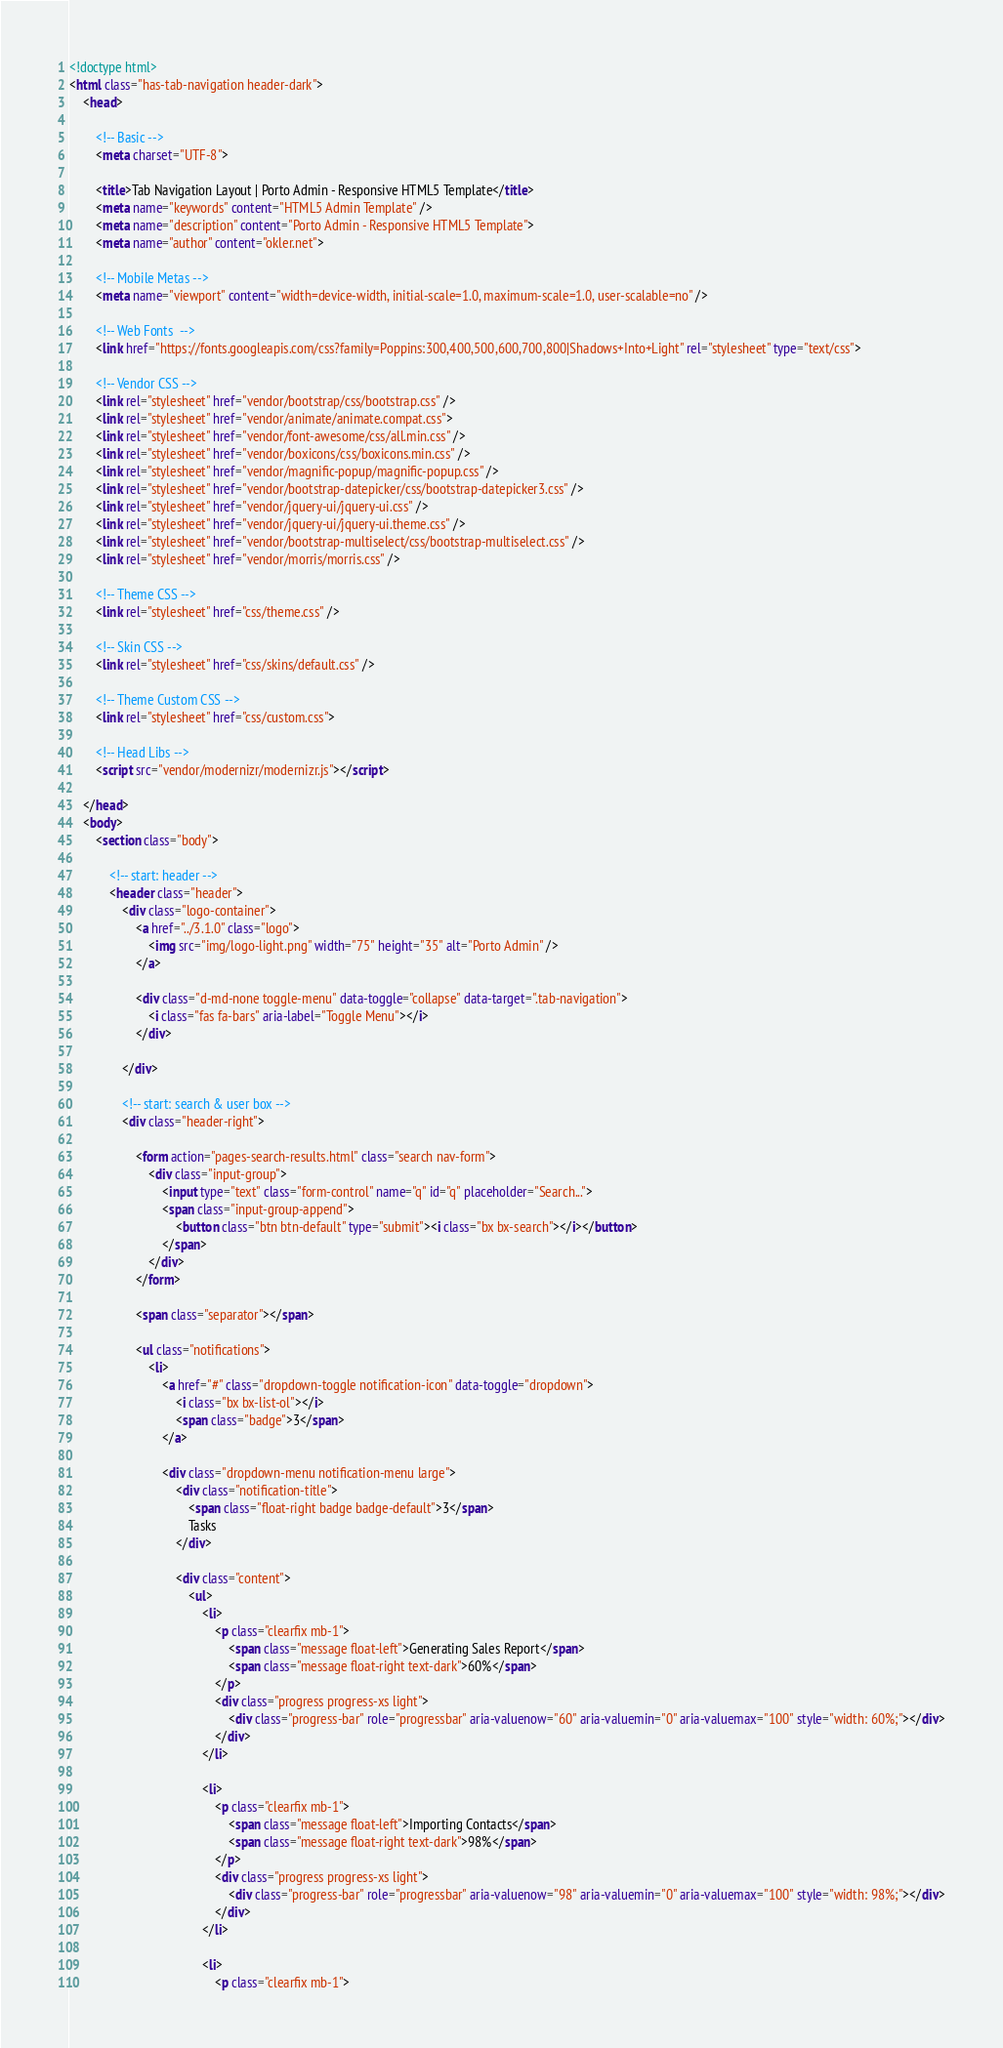Convert code to text. <code><loc_0><loc_0><loc_500><loc_500><_HTML_><!doctype html><html class="has-tab-navigation header-dark">
	<head>
		<!-- Basic -->
		<meta charset="UTF-8">
		<title>Tab Navigation Layout | Porto Admin - Responsive HTML5 Template</title>
		<meta name="keywords" content="HTML5 Admin Template" />
		<meta name="description" content="Porto Admin - Responsive HTML5 Template">
		<meta name="author" content="okler.net">
		<!-- Mobile Metas -->
		<meta name="viewport" content="width=device-width, initial-scale=1.0, maximum-scale=1.0, user-scalable=no" />
		<!-- Web Fonts  -->
		<link href="https://fonts.googleapis.com/css?family=Poppins:300,400,500,600,700,800|Shadows+Into+Light" rel="stylesheet" type="text/css">
		<!-- Vendor CSS -->
		<link rel="stylesheet" href="vendor/bootstrap/css/bootstrap.css" />		<link rel="stylesheet" href="vendor/animate/animate.compat.css">		<link rel="stylesheet" href="vendor/font-awesome/css/all.min.css" />		<link rel="stylesheet" href="vendor/boxicons/css/boxicons.min.css" />		<link rel="stylesheet" href="vendor/magnific-popup/magnific-popup.css" />		<link rel="stylesheet" href="vendor/bootstrap-datepicker/css/bootstrap-datepicker3.css" />		<link rel="stylesheet" href="vendor/jquery-ui/jquery-ui.css" />		<link rel="stylesheet" href="vendor/jquery-ui/jquery-ui.theme.css" />		<link rel="stylesheet" href="vendor/bootstrap-multiselect/css/bootstrap-multiselect.css" />		<link rel="stylesheet" href="vendor/morris/morris.css" />
		<!-- Theme CSS -->
		<link rel="stylesheet" href="css/theme.css" />
		<!-- Skin CSS -->
		<link rel="stylesheet" href="css/skins/default.css" />
		<!-- Theme Custom CSS -->
		<link rel="stylesheet" href="css/custom.css">
		<!-- Head Libs -->
		<script src="vendor/modernizr/modernizr.js"></script>
	</head>
	<body>
		<section class="body">
			<!-- start: header -->
			<header class="header">
				<div class="logo-container">
					<a href="../3.1.0" class="logo">
						<img src="img/logo-light.png" width="75" height="35" alt="Porto Admin" />
					</a>
					<div class="d-md-none toggle-menu" data-toggle="collapse" data-target=".tab-navigation">
						<i class="fas fa-bars" aria-label="Toggle Menu"></i>
					</div>
				</div>
				<!-- start: search & user box -->
				<div class="header-right">
					<form action="pages-search-results.html" class="search nav-form">
						<div class="input-group">
							<input type="text" class="form-control" name="q" id="q" placeholder="Search...">
							<span class="input-group-append">
								<button class="btn btn-default" type="submit"><i class="bx bx-search"></i></button>
							</span>
						</div>
					</form>
					<span class="separator"></span>
					<ul class="notifications">
						<li>
							<a href="#" class="dropdown-toggle notification-icon" data-toggle="dropdown">
								<i class="bx bx-list-ol"></i>
								<span class="badge">3</span>
							</a>
							<div class="dropdown-menu notification-menu large">
								<div class="notification-title">
									<span class="float-right badge badge-default">3</span>
									Tasks
								</div>
								<div class="content">
									<ul>
										<li>
											<p class="clearfix mb-1">
												<span class="message float-left">Generating Sales Report</span>
												<span class="message float-right text-dark">60%</span>
											</p>
											<div class="progress progress-xs light">
												<div class="progress-bar" role="progressbar" aria-valuenow="60" aria-valuemin="0" aria-valuemax="100" style="width: 60%;"></div>
											</div>
										</li>
										<li>
											<p class="clearfix mb-1">
												<span class="message float-left">Importing Contacts</span>
												<span class="message float-right text-dark">98%</span>
											</p>
											<div class="progress progress-xs light">
												<div class="progress-bar" role="progressbar" aria-valuenow="98" aria-valuemin="0" aria-valuemax="100" style="width: 98%;"></div>
											</div>
										</li>
										<li>
											<p class="clearfix mb-1"></code> 